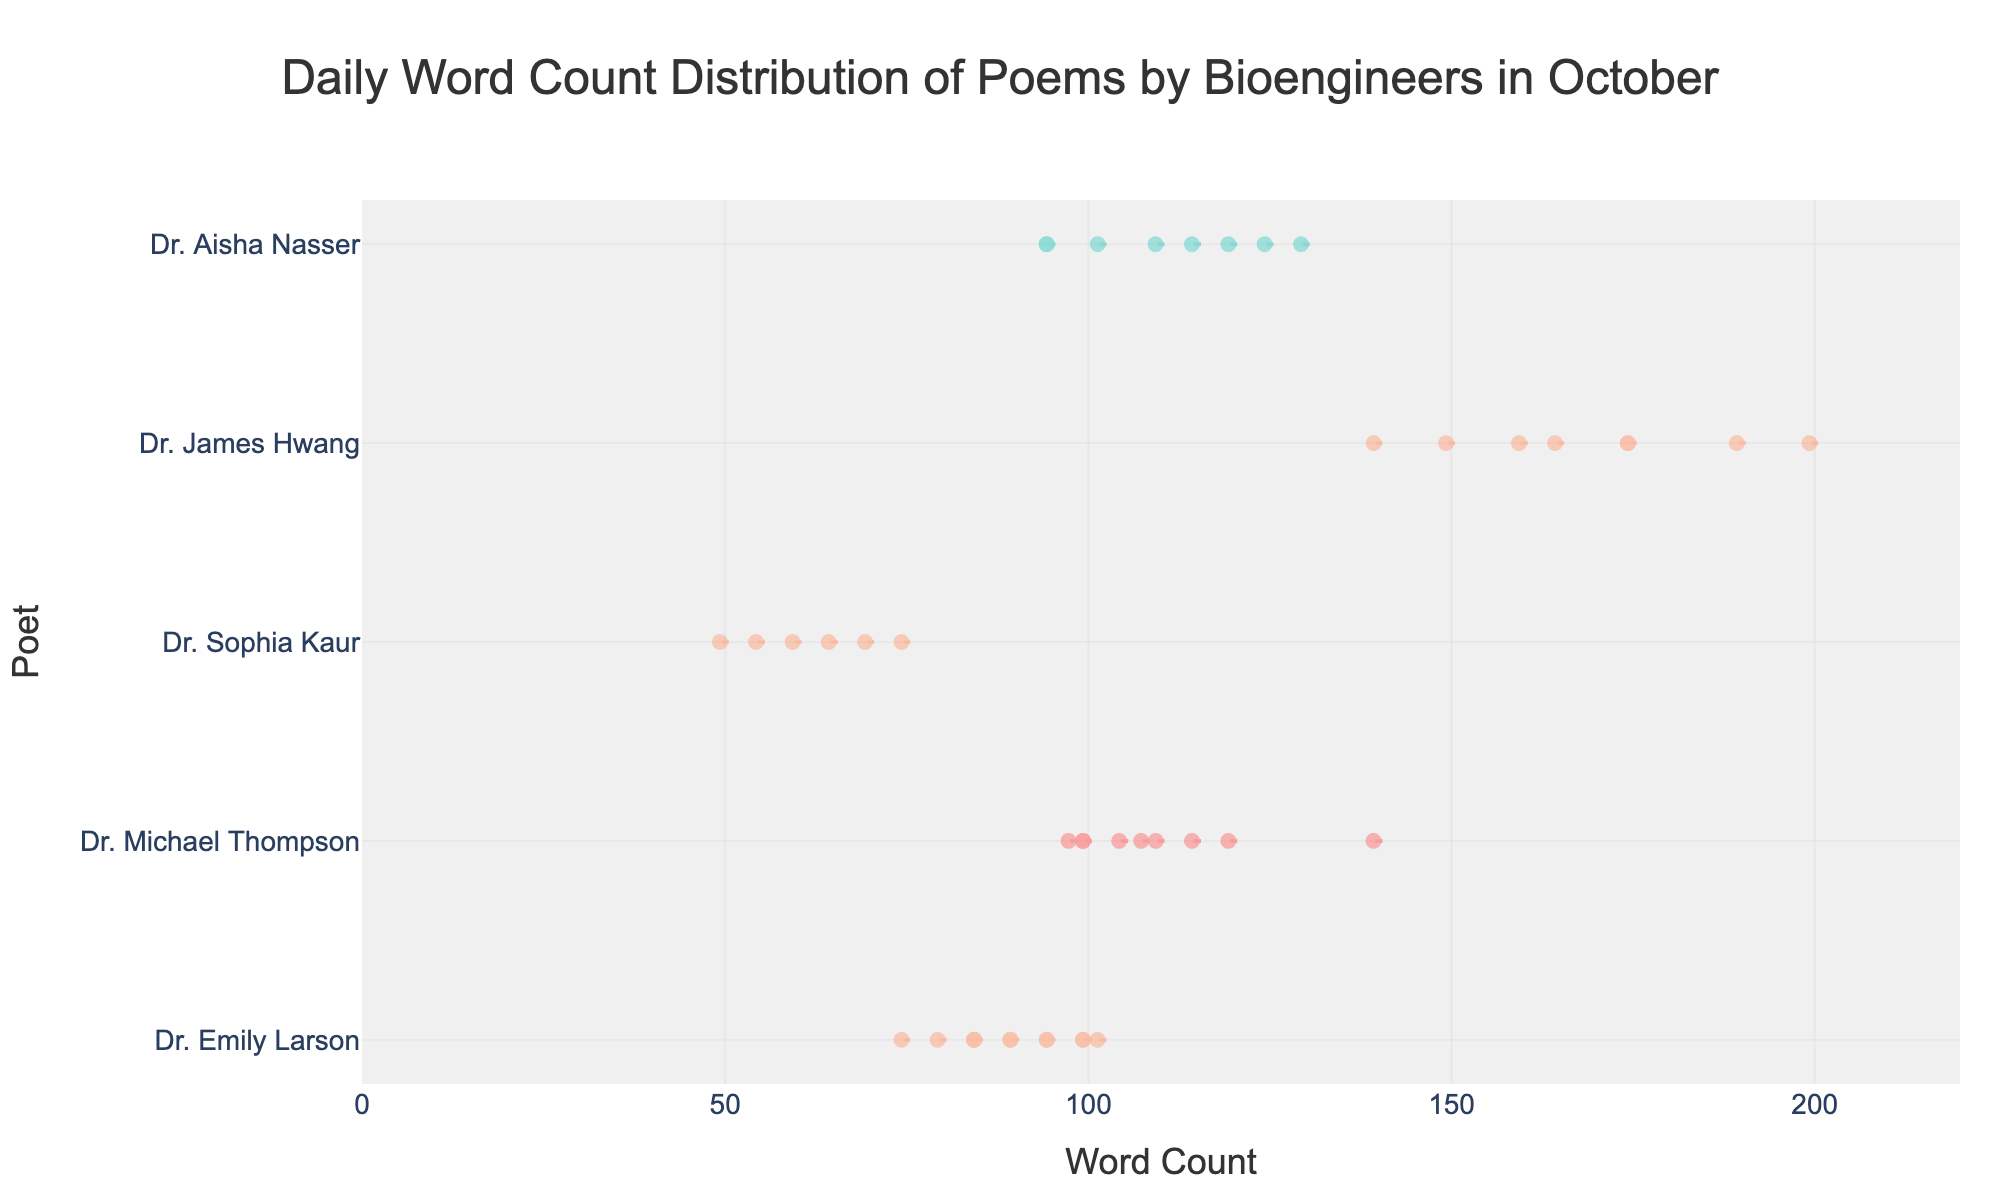What is the title of the figure? The title is located at the top of the figure. It is usually displayed in a larger font size and is centered.
Answer: Daily Word Count Distribution of Poems by Bioengineers in October Which poet has the highest maximum word count in the month of October? Look at the rightmost end of the distributions. The poet with the highest value (farthest to the right) has the highest maximum word count.
Answer: Dr. James Hwang How many poets are displayed in the figure? Count the unique names on the y-axis, as each represents a different poet.
Answer: 5 What is the average word count of poems written by Dr. Emily Larson? Collect all word count values for Dr. Emily Larson and compute the mean. The values are: [75, 85, 90, 95, 80, 100, 85, 90, 102, 95, 100, 85, 100]. Summing these gives 1187, and there are 13 entries, so 1187/13.
Answer: ~91.31 Who has the widest distribution of word counts? Compare the range (spread from minimum to maximum) of the distributions. The poet whose distribution spans the widest range has the widest distribution.
Answer: Dr. James Hwang Which poet has the narrowest distribution of word counts? Look for the poet with the narrowest range of values on the x-axis. This is determined by the shortest horizontal span of the violin plot.
Answer: Dr. Emily Larson What is the interquartile range (IQR) of Dr. Aisha Nasser's word counts? The IQR is the range between the first quartile (25th percentile) and the third quartile (75th percentile). These values are typically indicated as the width of the "box" within the violin plot. Estimate these values from the plot.
Answer: ~20 to 130 Is there any poet whose mean word count lies around 100 words? Identify the mean lines (typically a horizontal line inside the violin plot) and locate the ones that align with the 100-word count on the x-axis.
Answer: Yes, Dr. Michael Thompson and Dr. Sophia Kaur For which poet do the word count distributions exhibit the most outliers? Outliers are usually represented by individual points outside the violin plot. Look for the poet with the most visible individual points not within the main body of the violin.
Answer: Dr. James Hwang Comparing Dr. Michael Thompson and Dr. Sophia Kaur, who has a more consistent word count? Consistency can be judged by looking at how spread out the data points are. A more concentrated violin plot indicates more consistent word counts.
Answer: Dr. Sophia Kaur 